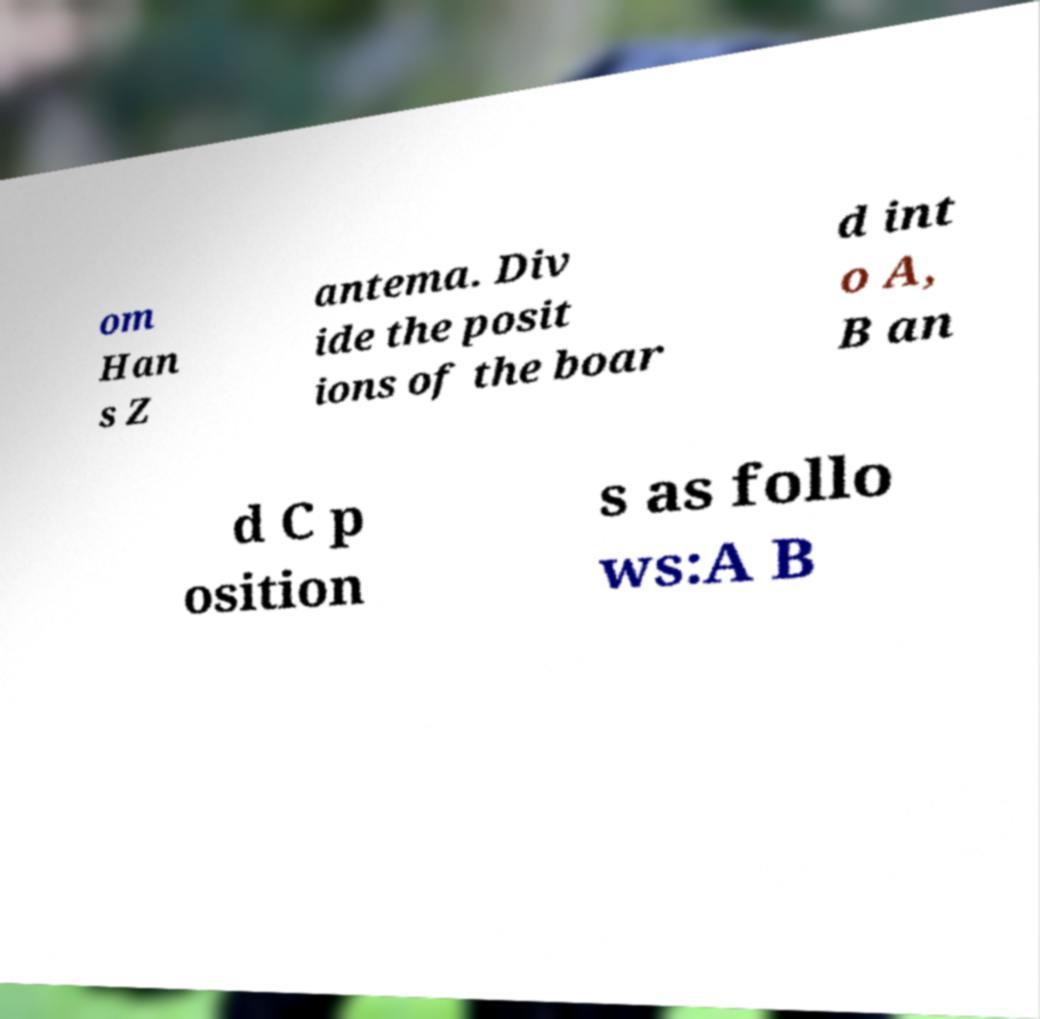Please read and relay the text visible in this image. What does it say? om Han s Z antema. Div ide the posit ions of the boar d int o A, B an d C p osition s as follo ws:A B 